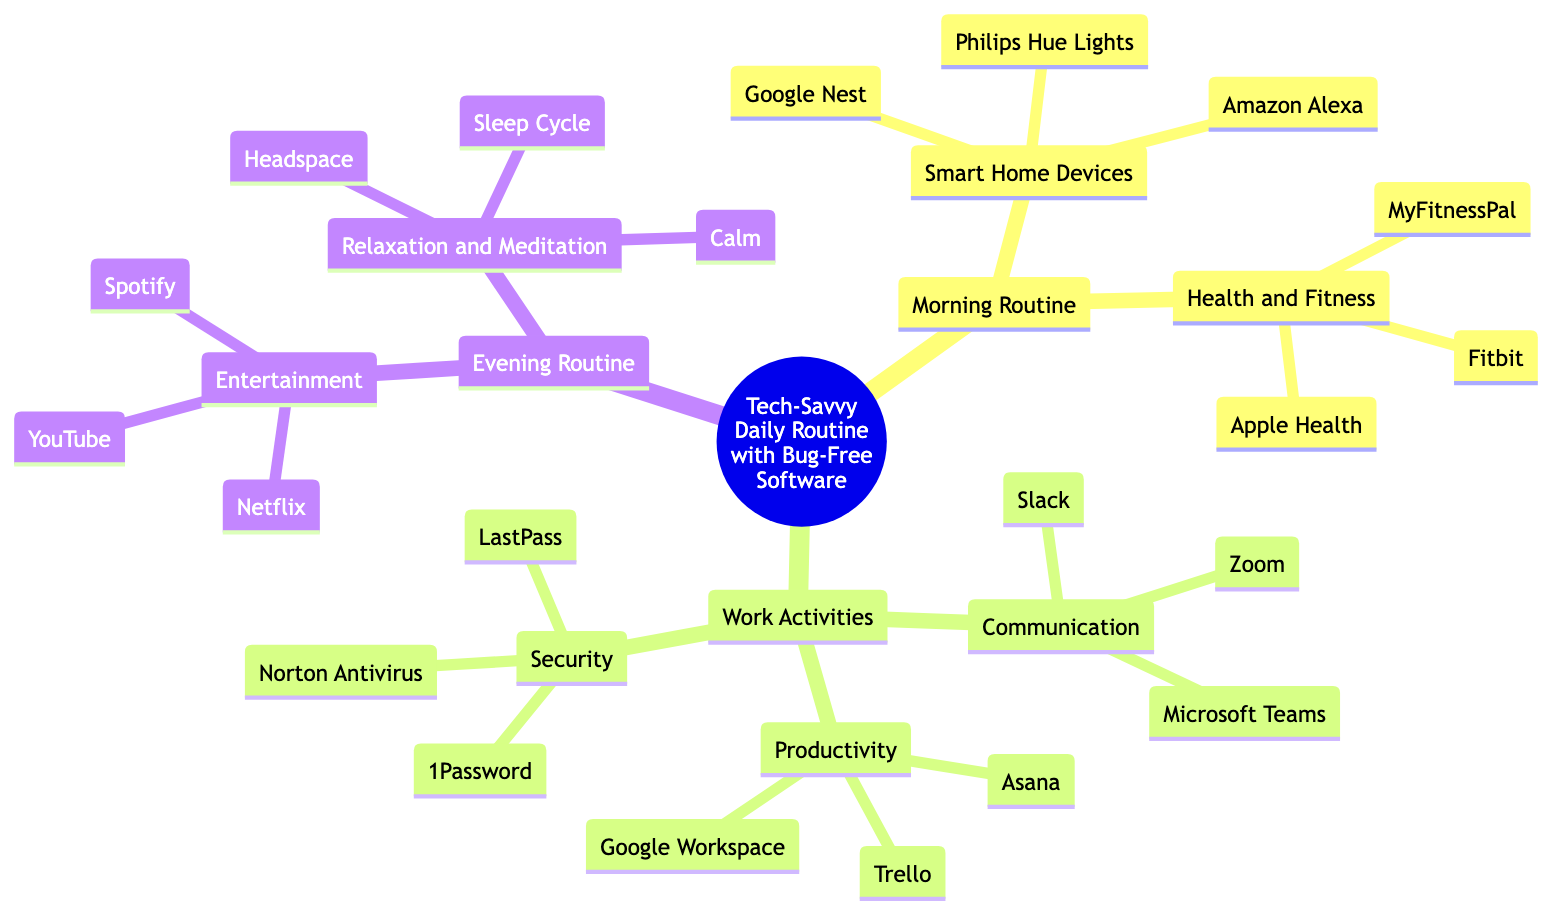What are the elements under the "Smart Home Devices" sub-branch? The "Smart Home Devices" sub-branch includes three elements: Amazon Alexa, Google Nest, and Philips Hue Lights. This is directly observed in the diagram under the relevant branch.
Answer: Amazon Alexa, Google Nest, Philips Hue Lights How many sub-branches are in the "Work Activities" branch? The "Work Activities" branch contains three sub-branches: Communication, Productivity, and Security. Counting these explicitly shows that there are three.
Answer: 3 Which element is part of the "Health and Fitness" category? Among the elements listed under the "Health and Fitness" category, Fitbit is explicitly mentioned. This can be identified by looking at the elements listed under that particular sub-branch.
Answer: Fitbit What element is listed under both "Communication" and "Work Activities"? Zoom is listed under the "Communication" sub-branch, which is part of the broader "Work Activities" branch. By tracing back to the parent branches, we can confirm it belongs to both categories.
Answer: Zoom How many elements are in the "Evening Routine"? The "Evening Routine" sub-branch has two main sub-branches: Entertainment and Relaxation and Meditation, each containing three elements. Adding these gives a total of six elements in this section.
Answer: 6 Which productivity tool is included under "Productivity"? Trello is one of the elements listed under the "Productivity" sub-branch in the diagram. By examining that specific section, it can be easily identified.
Answer: Trello What is the purpose of the "Security" sub-branch? The "Security" sub-branch contains elements that are geared towards safeguarding digital information, including Norton Antivirus, LastPass, and 1Password. This can be understood by analyzing the elements listed under this branch.
Answer: Safeguarding digital information How many branches are focused on routines in the diagram? There are two main branches dedicated to routines: "Morning Routine" and "Evening Routine". By looking at the top-level branches of the mind map, we can see the two distinct routine categories.
Answer: 2 Which app is recommended for "Relaxation and Meditation"? Calm is specifically listed as one of the elements under the "Relaxation and Meditation" sub-branch. This can be confirmed by reviewing the elements associated with that sub-branch.
Answer: Calm 